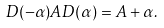Convert formula to latex. <formula><loc_0><loc_0><loc_500><loc_500>D ( - \alpha ) A D ( \alpha ) = A + \alpha .</formula> 